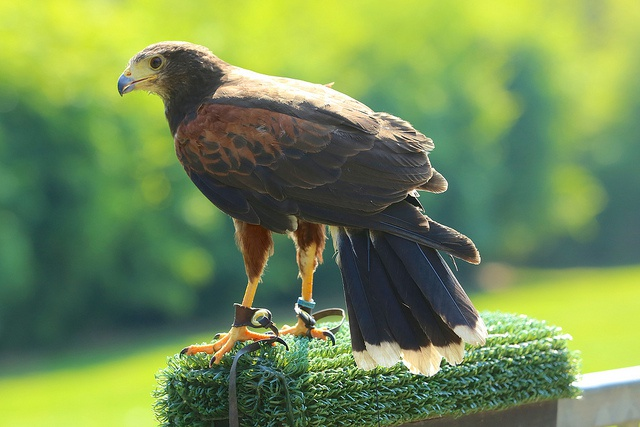Describe the objects in this image and their specific colors. I can see a bird in yellow, black, gray, and maroon tones in this image. 